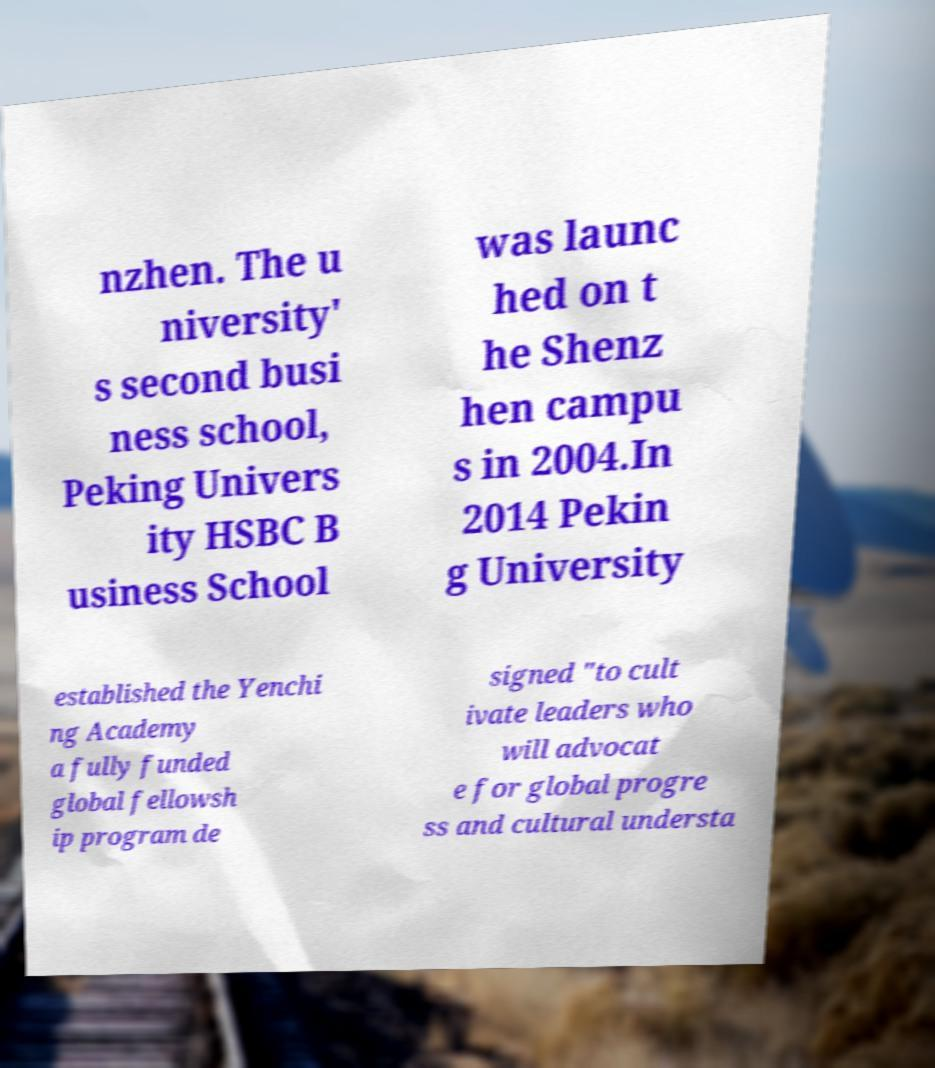Could you assist in decoding the text presented in this image and type it out clearly? nzhen. The u niversity' s second busi ness school, Peking Univers ity HSBC B usiness School was launc hed on t he Shenz hen campu s in 2004.In 2014 Pekin g University established the Yenchi ng Academy a fully funded global fellowsh ip program de signed "to cult ivate leaders who will advocat e for global progre ss and cultural understa 